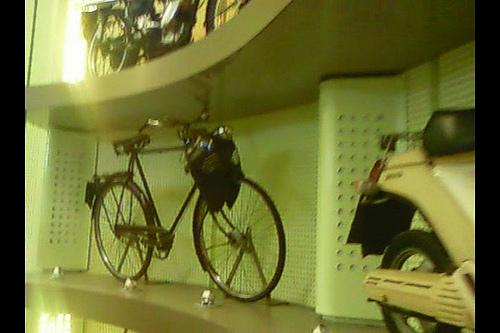Analyze the interaction between the bicycles and other objects in the display. The bicycles interact with the silver shelves that display them, as well as with additional elements such as lights, which highlight and draw attention to the bikes. How many bicycles are visible in the image? Two bicycles are visible in the image. What kind of sentiment does this image evoke? The image evokes a sense of organization and attention to detail. Mention one distinct characteristic of the front wheel of the bicycle in the image. The front wheel is thin. Identify and list the two dominant colors present in the image. Green and silver Briefly describe the presentation of the bicycles in this image. The bicycles are displayed on a silver shelf, one above the other, with various parts like handlebars and wheels emphasized. Count the total number of wheels visible in the image. There are four wheels visible in the image. What type of lighting is present around the bicycles in the image? There is a small silver light sticking out of the shelf and another light near the partially visible bicycle. What is the primary focus of this image? The primary focus is displaying bicycles on a shelf. Provide a detailed description of the bicycle seat in the image. The bicycle seat is small, black, and appears to be relatively flat. 